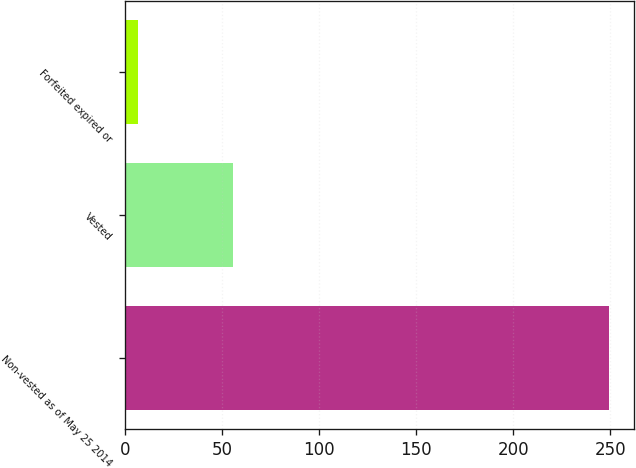Convert chart to OTSL. <chart><loc_0><loc_0><loc_500><loc_500><bar_chart><fcel>Non-vested as of May 25 2014<fcel>Vested<fcel>Forfeited expired or<nl><fcel>249.5<fcel>55.7<fcel>6.3<nl></chart> 